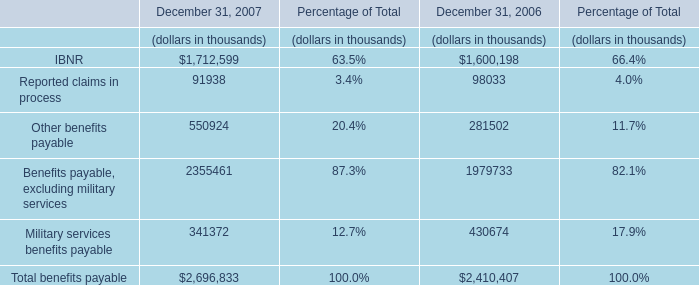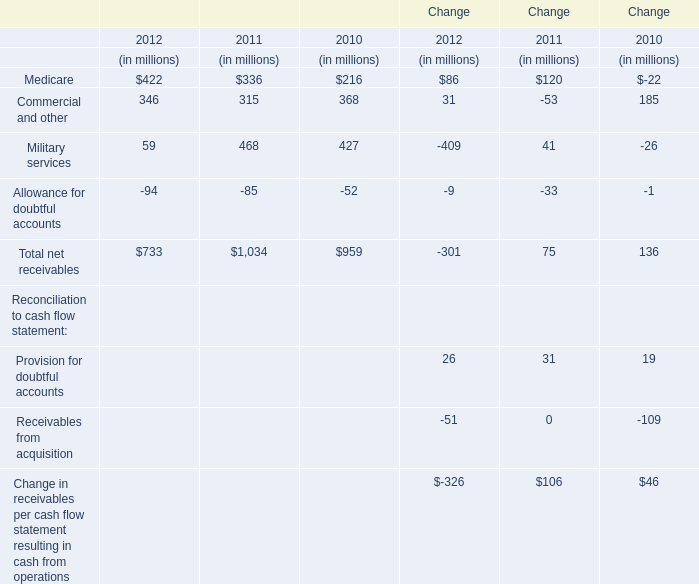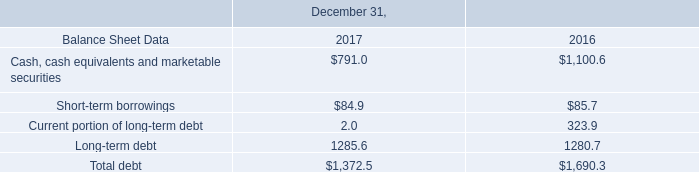What is the sum of the Allowance for doubtful accounts in the years where Commercial and other is positive? (in million) 
Computations: ((-94 - 85) - 52)
Answer: -231.0. 